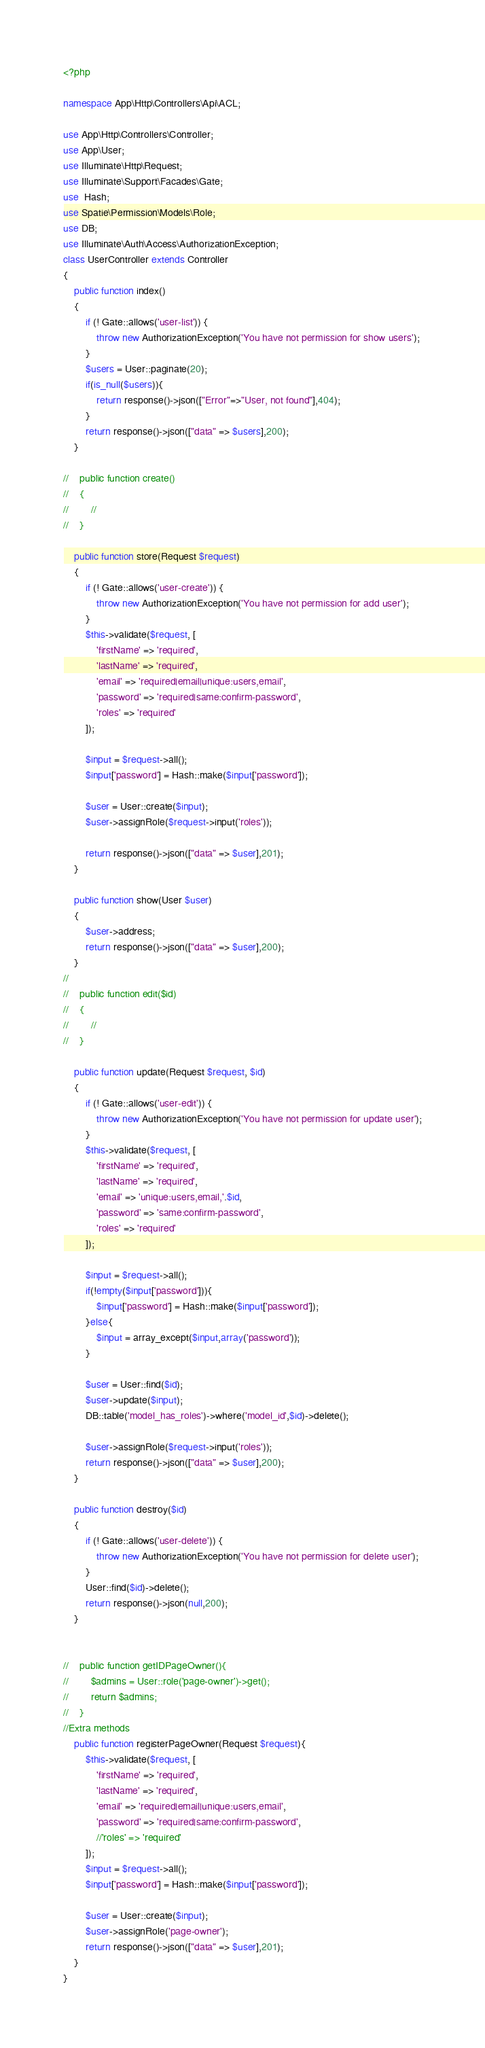Convert code to text. <code><loc_0><loc_0><loc_500><loc_500><_PHP_><?php

namespace App\Http\Controllers\Api\ACL;

use App\Http\Controllers\Controller;
use App\User;
use Illuminate\Http\Request;
use Illuminate\Support\Facades\Gate;
use  Hash;
use Spatie\Permission\Models\Role;
use DB;
use Illuminate\Auth\Access\AuthorizationException;
class UserController extends Controller
{
    public function index()
    {
        if (! Gate::allows('user-list')) {
            throw new AuthorizationException('You have not permission for show users');
        }
        $users = User::paginate(20);
        if(is_null($users)){
            return response()->json(["Error"=>"User, not found"],404);
        }
        return response()->json(["data" => $users],200);
    }

//    public function create()
//    {
//        //
//    }

    public function store(Request $request)
    {
        if (! Gate::allows('user-create')) {
            throw new AuthorizationException('You have not permission for add user');
        }
        $this->validate($request, [
            'firstName' => 'required',
            'lastName' => 'required',
            'email' => 'required|email|unique:users,email',
            'password' => 'required|same:confirm-password',
            'roles' => 'required'
        ]);

        $input = $request->all();
        $input['password'] = Hash::make($input['password']);

        $user = User::create($input);
        $user->assignRole($request->input('roles'));

        return response()->json(["data" => $user],201);
    }

    public function show(User $user)
    {
        $user->address;
        return response()->json(["data" => $user],200);
    }
//
//    public function edit($id)
//    {
//        //
//    }

    public function update(Request $request, $id)
    {
        if (! Gate::allows('user-edit')) {
            throw new AuthorizationException('You have not permission for update user');
        }
        $this->validate($request, [
            'firstName' => 'required',
            'lastName' => 'required',
            'email' => 'unique:users,email,'.$id,
            'password' => 'same:confirm-password',
            'roles' => 'required'
        ]);

        $input = $request->all();
        if(!empty($input['password'])){
            $input['password'] = Hash::make($input['password']);
        }else{
            $input = array_except($input,array('password'));
        }

        $user = User::find($id);
        $user->update($input);
        DB::table('model_has_roles')->where('model_id',$id)->delete();

        $user->assignRole($request->input('roles'));
        return response()->json(["data" => $user],200);
    }

    public function destroy($id)
    {
        if (! Gate::allows('user-delete')) {
            throw new AuthorizationException('You have not permission for delete user');
        }
        User::find($id)->delete();
        return response()->json(null,200);
    }


//    public function getIDPageOwner(){
//        $admins = User::role('page-owner')->get();
//        return $admins;
//    }
//Extra methods
    public function registerPageOwner(Request $request){
        $this->validate($request, [
            'firstName' => 'required',
            'lastName' => 'required',
            'email' => 'required|email|unique:users,email',
            'password' => 'required|same:confirm-password',
            //'roles' => 'required'
        ]);
        $input = $request->all();
        $input['password'] = Hash::make($input['password']);

        $user = User::create($input);
        $user->assignRole('page-owner');
        return response()->json(["data" => $user],201);
    }
}
</code> 